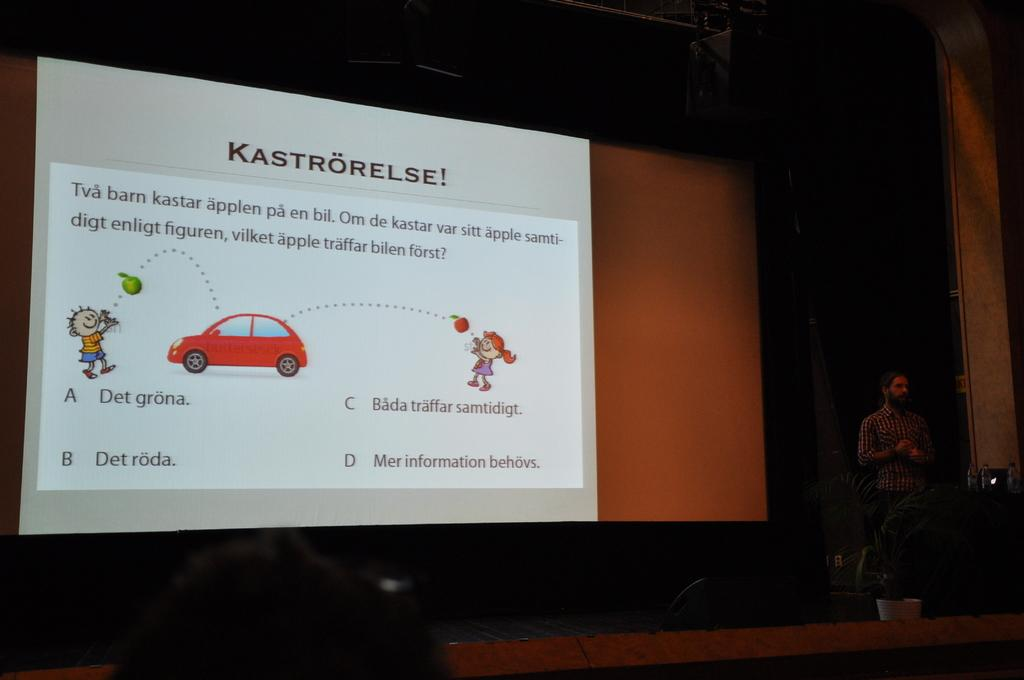What is happening in the image? There is a person on a stage in the image. What can be seen behind the person on the stage? There is a screen in the background of the image. What is being displayed on the screen? The screen displays images and text. Can you see a trail leading to the ocean in the image? There is no trail or ocean present in the image; it features a person on a stage with a screen in the background. 